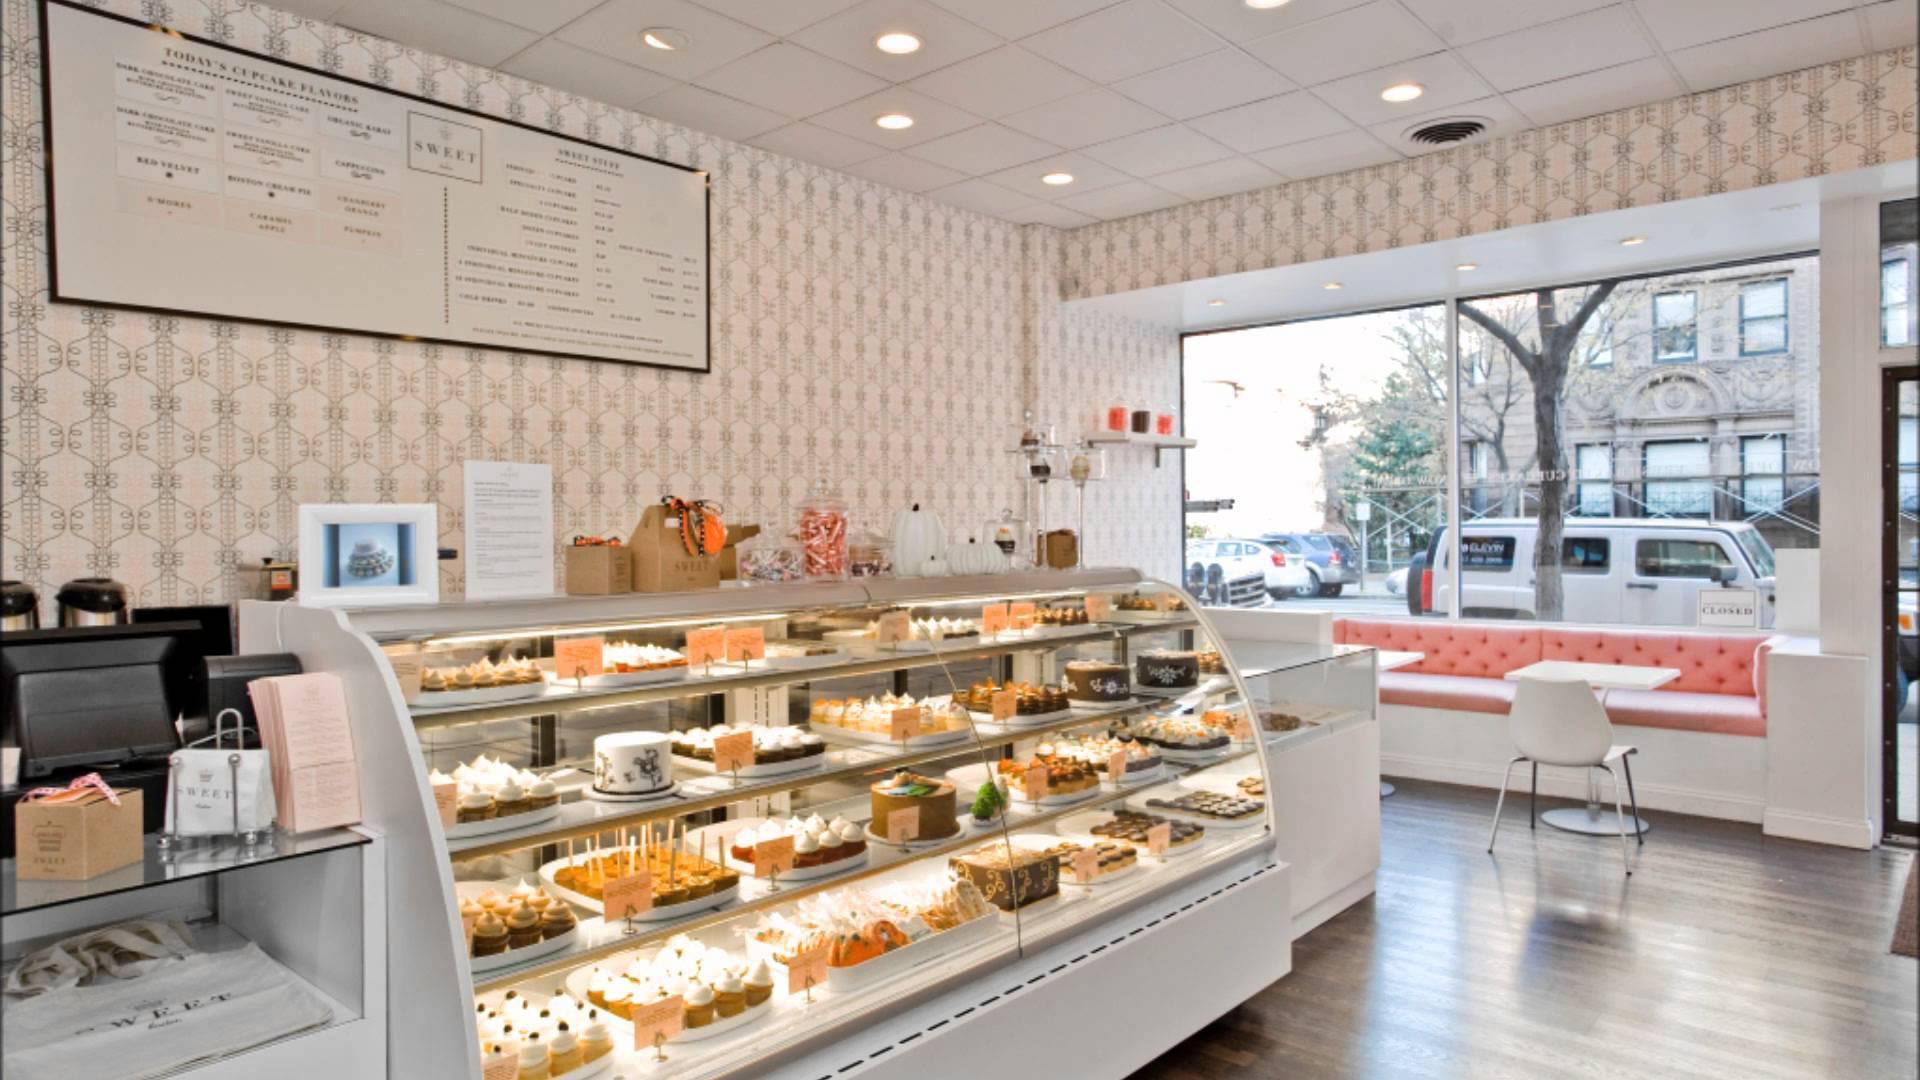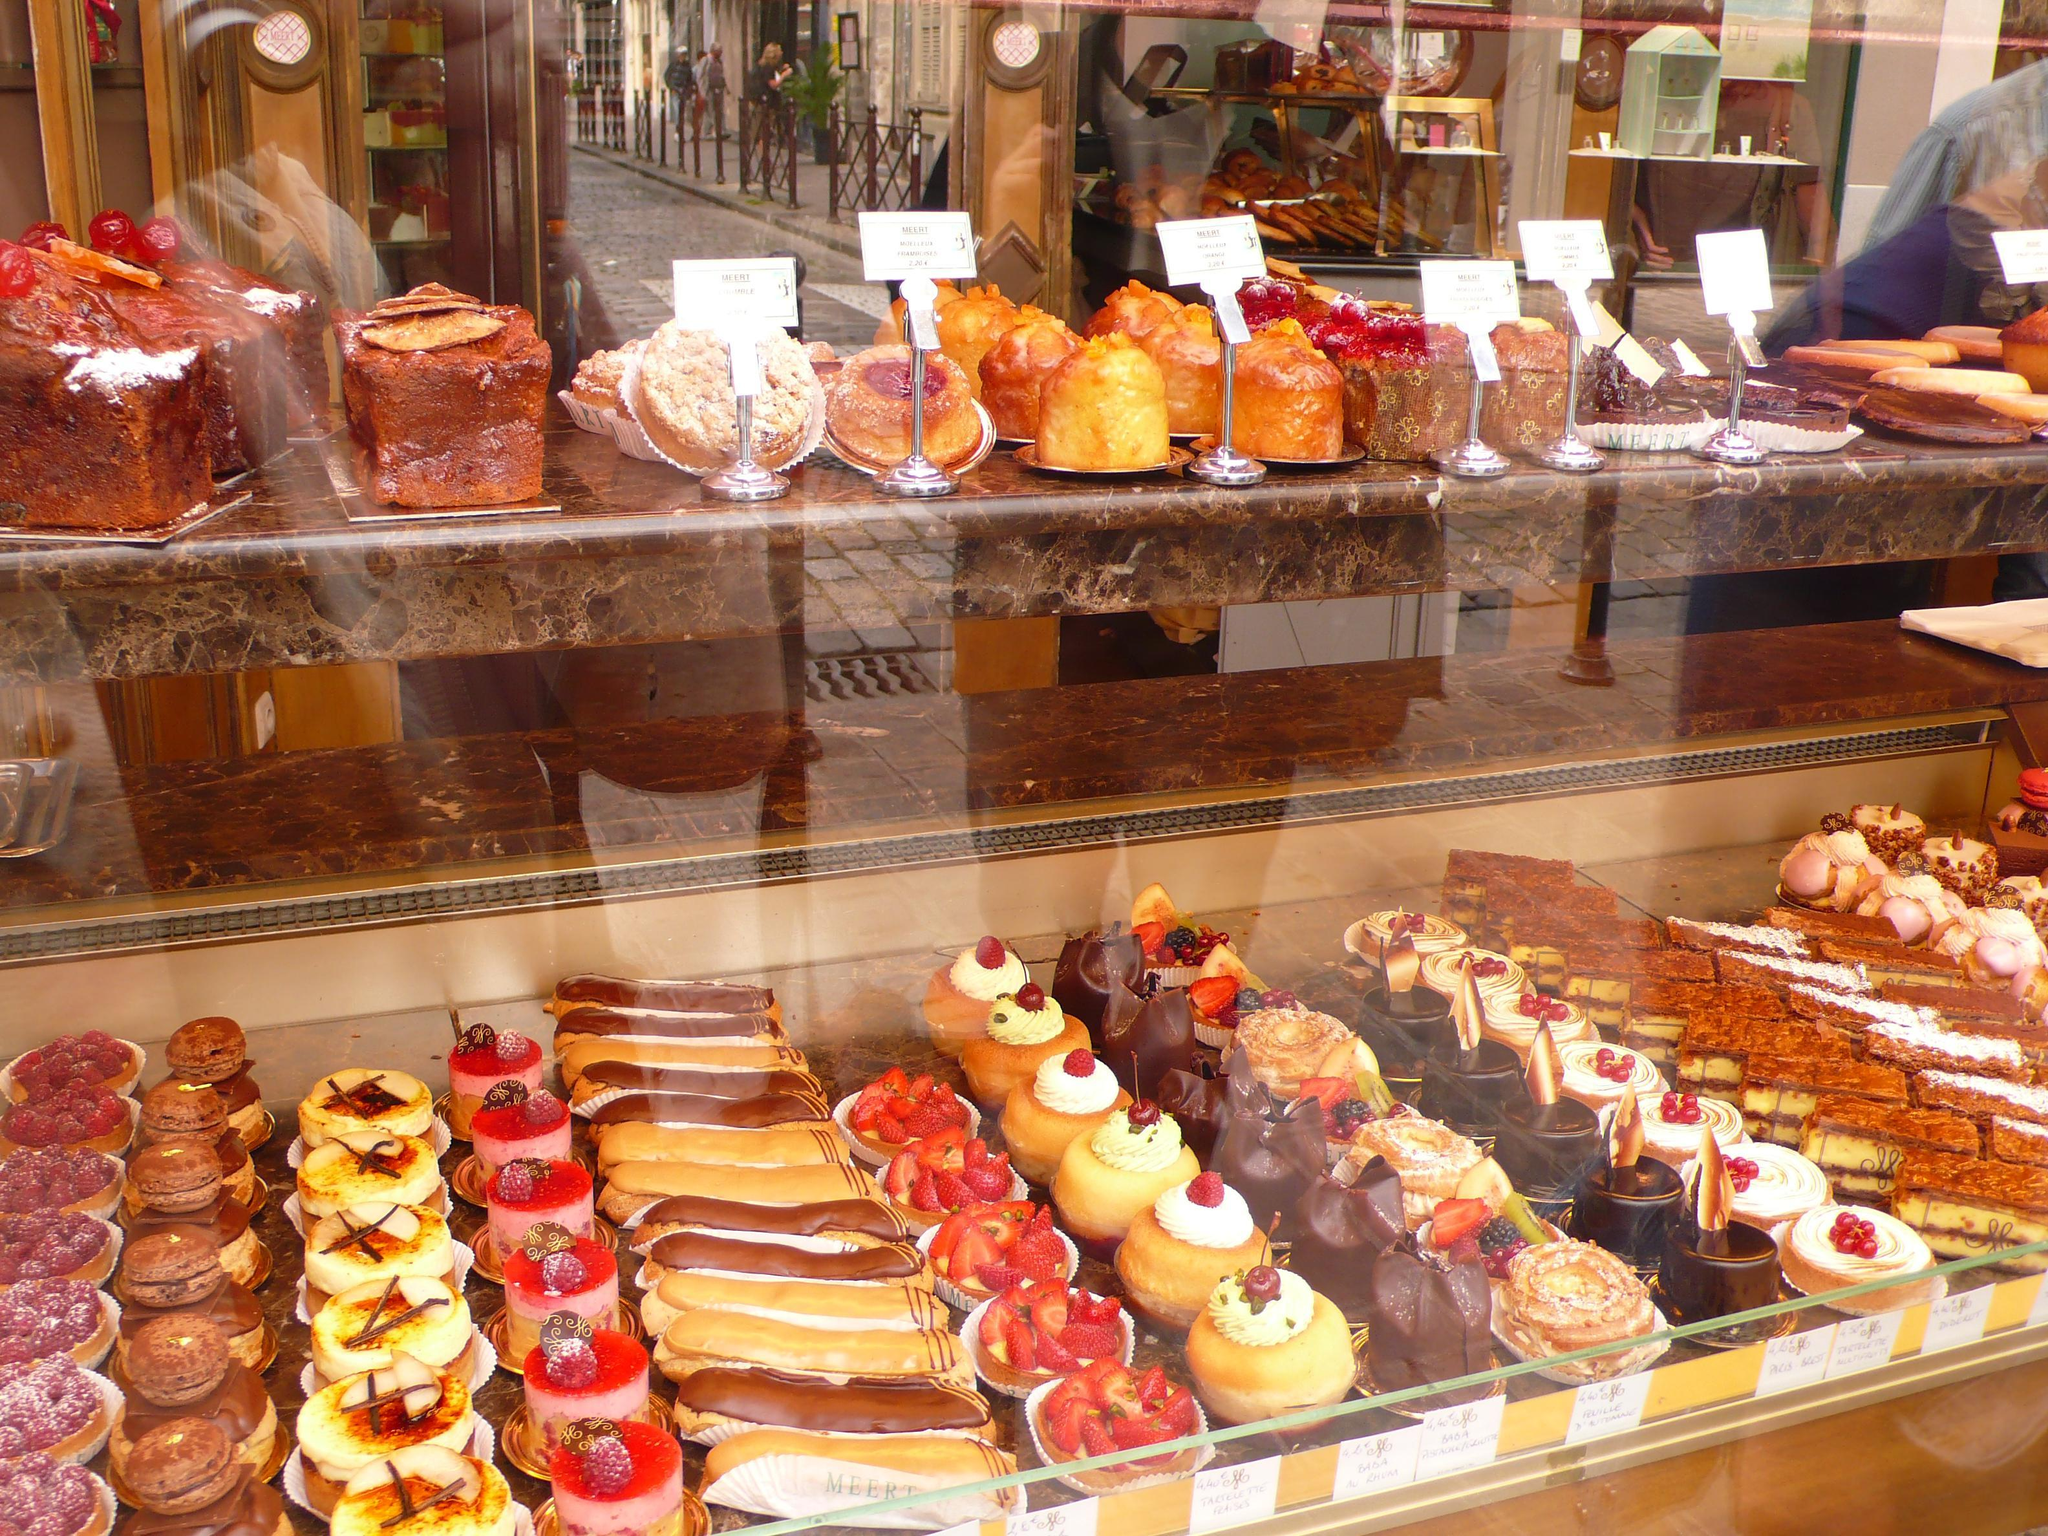The first image is the image on the left, the second image is the image on the right. Given the left and right images, does the statement "A black railed wheeled display is on the right in one image." hold true? Answer yes or no. No. 